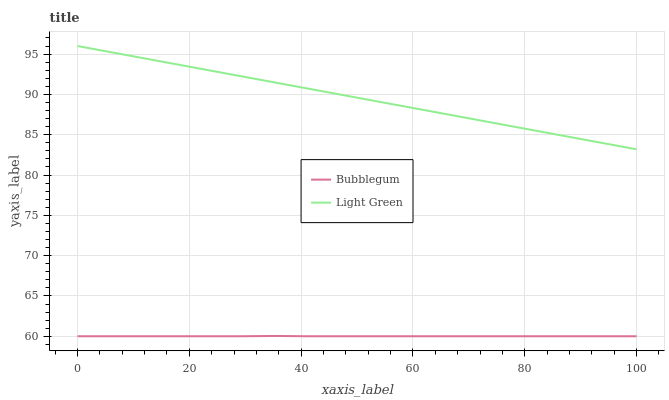Does Bubblegum have the minimum area under the curve?
Answer yes or no. Yes. Does Bubblegum have the maximum area under the curve?
Answer yes or no. No. Is Bubblegum the smoothest?
Answer yes or no. No. Does Bubblegum have the highest value?
Answer yes or no. No. Is Bubblegum less than Light Green?
Answer yes or no. Yes. Is Light Green greater than Bubblegum?
Answer yes or no. Yes. Does Bubblegum intersect Light Green?
Answer yes or no. No. 